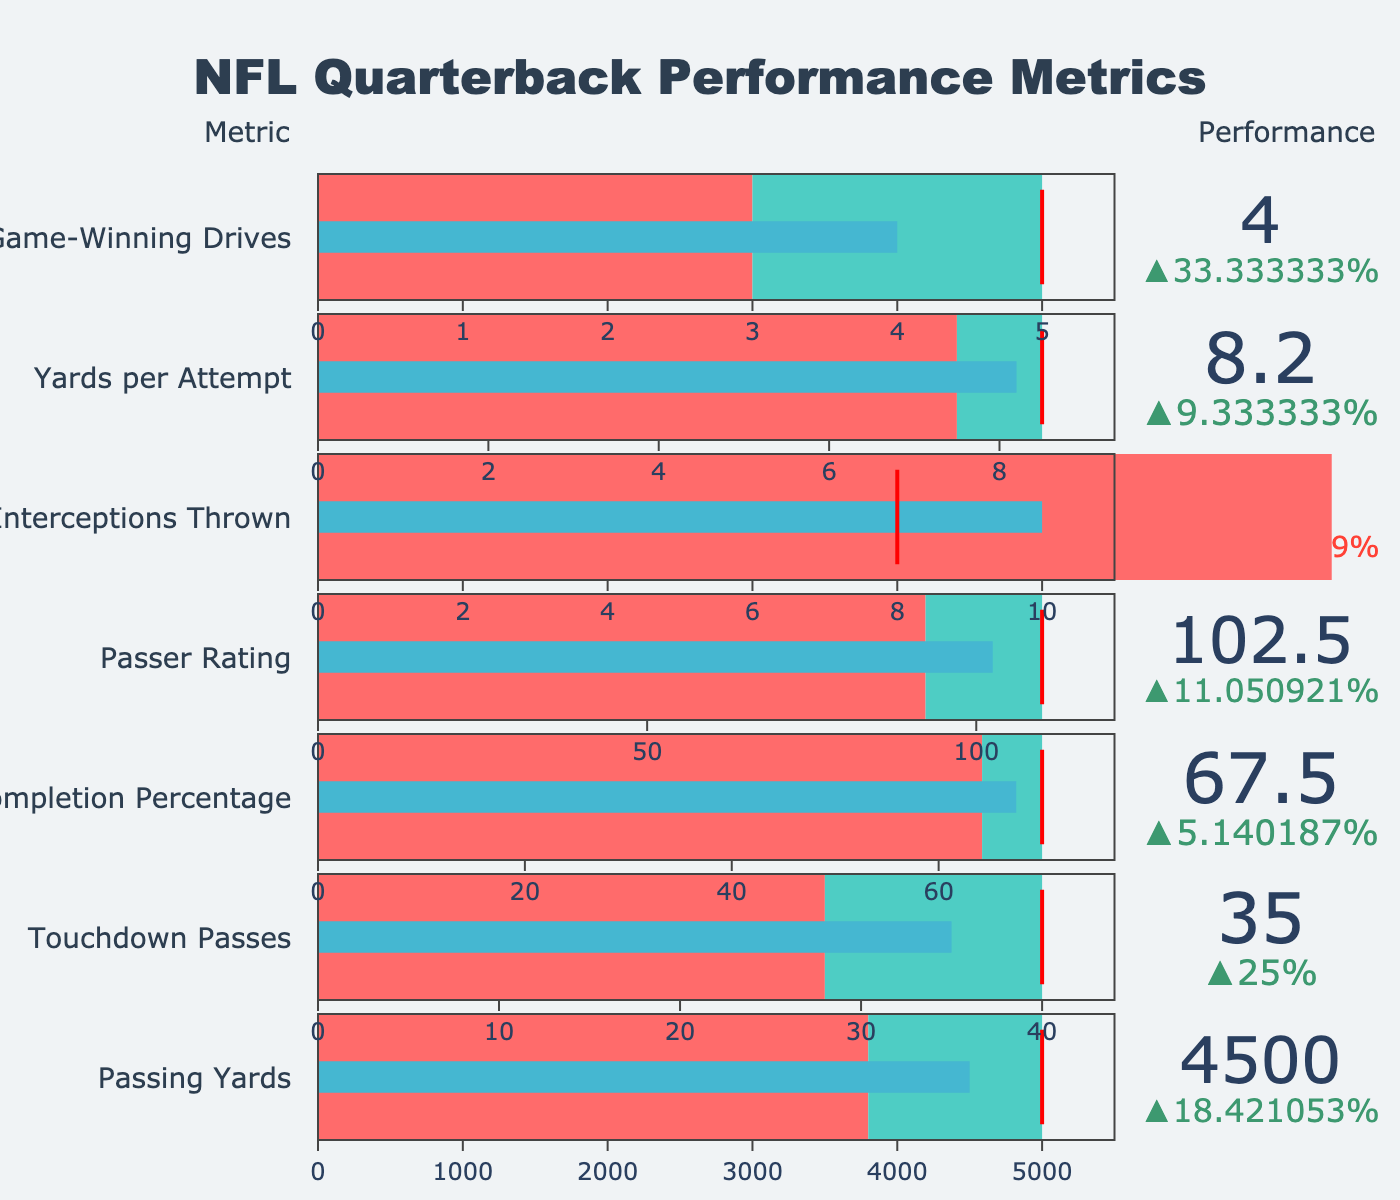what's the title of the figure? The title is usually placed at the top of the chart and is designed to give an overall summary of what the chart is about. The title in this case is "NFL Quarterback Performance Metrics."
Answer: NFL Quarterback Performance Metrics what are the three sections represented in the gauges? Each gauge has three sections: a red section which indicates the range of values below the average, a turquoise section indicating the range between the average and the target, and a blue section representing the actual score achieved by the quarterback.
Answer: red, turquoise, blue how much higher is the actual completion percentage compared to the league average? The league average for completion percentage is 64.2%. The actual percentage is 67.5%. The difference can be calculated as 67.5% - 64.2% = 3.3%.
Answer: 3.3% for the metric with the lowest actual value, is the actual value above the average? The metric with the lowest actual value is Interceptions Thrown at 10. The average for this metric is 14, so the actual value is below the average.
Answer: No 